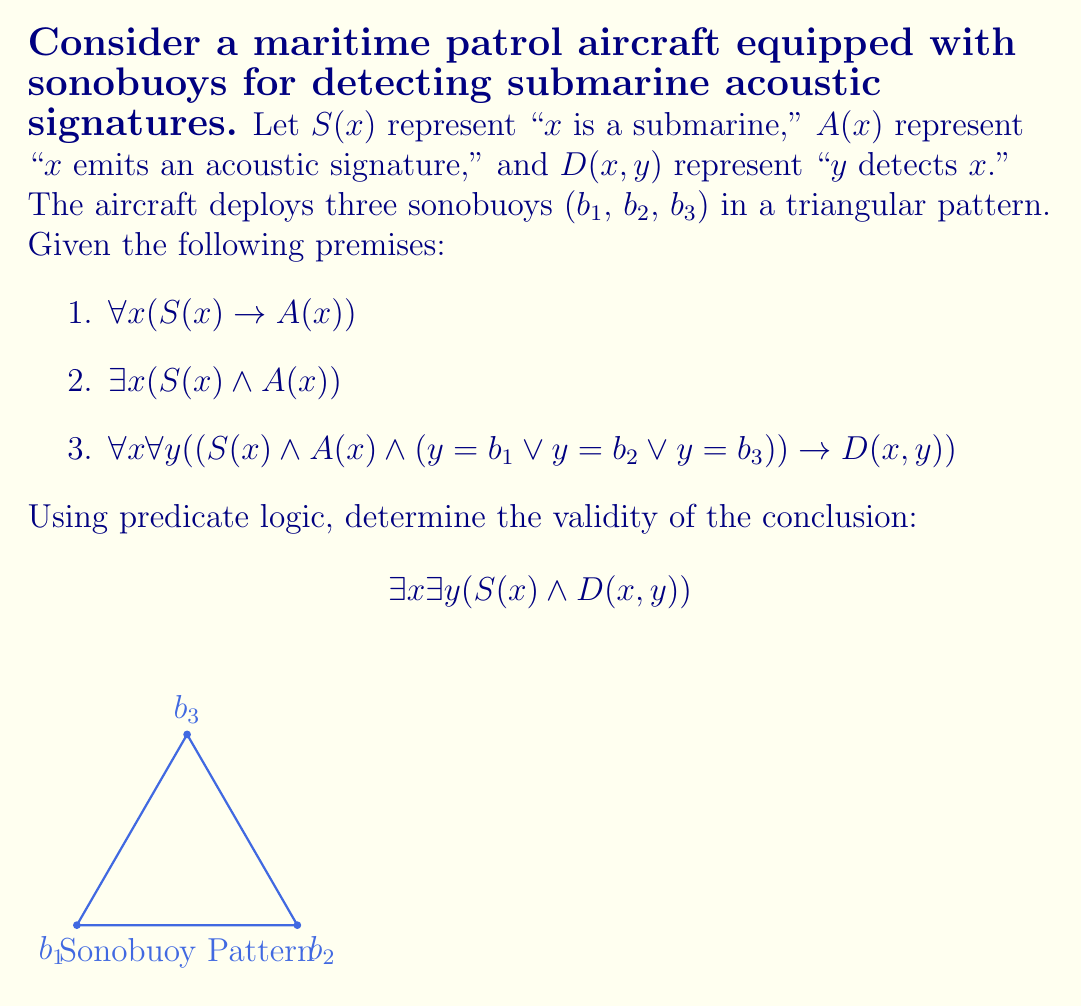What is the answer to this math problem? Let's analyze this step-by-step using predicate logic:

1) From premise 1, we know that all submarines emit acoustic signatures:
   $\forall x (S(x) \rightarrow A(x))$

2) Premise 2 states that there exists at least one submarine that emits an acoustic signature:
   $\exists x (S(x) \wedge A(x))$

3) Premise 3 tells us that if something is a submarine and emits an acoustic signature, it will be detected by at least one of the sonobuoys:
   $\forall x \forall y ((S(x) \wedge A(x) \wedge (y=b1 \vee y=b2 \vee y=b3)) \rightarrow D(x,y))$

4) From premise 2, we can use existential instantiation to say that there is a specific submarine, let's call it 's', such that:
   $S(s) \wedge A(s)$

5) Since $S(s)$ and $A(s)$ are true, and we know that $y=b1 \vee y=b2 \vee y=b3$ is true for our sonobuoys, we can apply premise 3:
   $(S(s) \wedge A(s) \wedge (y=b1 \vee y=b2 \vee y=b3)) \rightarrow D(s,y)$

6) The antecedent of this implication is true, so we can conclude:
   $D(s,y)$ where $y$ is one of $b1$, $b2$, or $b3$

7) This means there exists a submarine $s$ and a sonobuoy $y$ such that $y$ detects $s$:
   $\exists x \exists y (S(x) \wedge D(x,y))$

Thus, we have shown that the conclusion follows logically from the premises.
Answer: Valid 